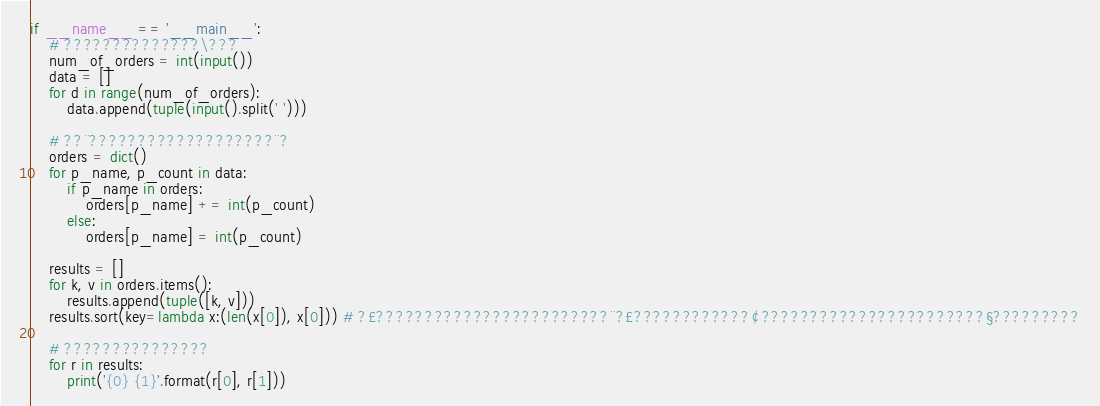Convert code to text. <code><loc_0><loc_0><loc_500><loc_500><_Python_>if __name__ == '__main__':
    # ??????????????\???
    num_of_orders = int(input())
    data = []
    for d in range(num_of_orders):
        data.append(tuple(input().split(' ')))

    # ??¨???????????????????¨?
    orders = dict()
    for p_name, p_count in data:
        if p_name in orders:
            orders[p_name] += int(p_count)
        else:
            orders[p_name] = int(p_count)

    results = []
    for k, v in orders.items():
        results.append(tuple([k, v]))
    results.sort(key=lambda x:(len(x[0]), x[0])) # ?£????????????????????????¨?£????????????¢???????????????????????§?????????

    # ???????????????
    for r in results:
        print('{0} {1}'.format(r[0], r[1]))</code> 